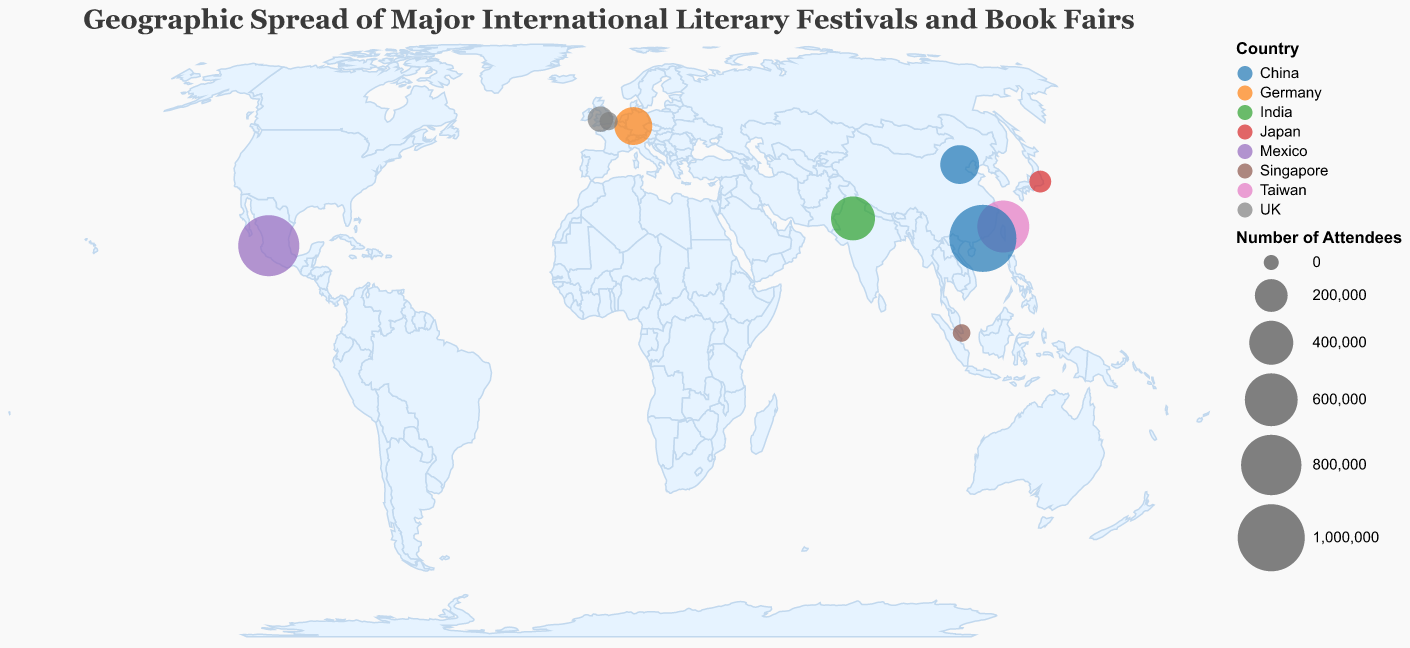Which event has the highest number of attendees? From the visualization, the size of each circle represents the number of attendees. The largest circle corresponds to the Hong Kong Book Fair held in Hong Kong, China.
Answer: Hong Kong Book Fair Which countries have more than one literary event represented on the map? By observing the color categories, it is evident that the UK and China have multiple events. The UK has the London Book Fair and Hay Festival, while China has the Hong Kong Book Fair and Beijing International Book Fair.
Answer: UK and China What is the total number of attendees for events held in Asia? Summing the number of attendees for each event in Asian cities: Taipei (580,000), Hong Kong (1,000,000), Singapore (20,000), Tokyo (60,000), and Beijing (300,000). The total is 580,000 + 1,000,000 + 20,000 + 60,000 + 300,000 = 1,960,000.
Answer: 1,960,000 Which event is located furthest south? The smallest latitude value corresponds to the event located furthest south. Singapore Writers Festival, held in Singapore, has a latitude of 1.3521.
Answer: Singapore Writers Festival How many attendees do the events in Europe attract altogether? Summing the number of attendees for each event in European cities: Frankfurt (285,000), London (25,000), and Hay-on-Wye (100,000). The total is 285,000 + 25,000 + 100,000 = 410,000.
Answer: 410,000 Which event in North America has the highest number of attendees? Observing the events in North America, Guadalajara International Book Fair held in Guadalajara, Mexico, has the highest number of attendees with 820,000.
Answer: Guadalajara International Book Fair Which country has the event with the second highest number of attendees? After the Hong Kong Book Fair (1,000,000 attendees), the Guadalajara International Book Fair in Mexico has the second highest number of attendees with 820,000.
Answer: Mexico What is the average number of attendees for all events shown on the map? First, find the total number of attendees by adding each event's attendees, then divide by the number of events. The total is 580,000 + 285,000 + 25,000 + 400,000 + 1,000,000 + 20,000 + 100,000 + 60,000 + 300,000 + 820,000 = 3,590,000. There are 10 events, so the average is 3,590,000 / 10 = 359,000.
Answer: 359,000 Which UK event has more attendees, and by how much? Comparing London Book Fair (25,000 attendees) and Hay Festival (100,000 attendees), the Hay Festival has more attendees. The difference is 100,000 - 25,000 = 75,000.
Answer: Hay Festival by 75,000 